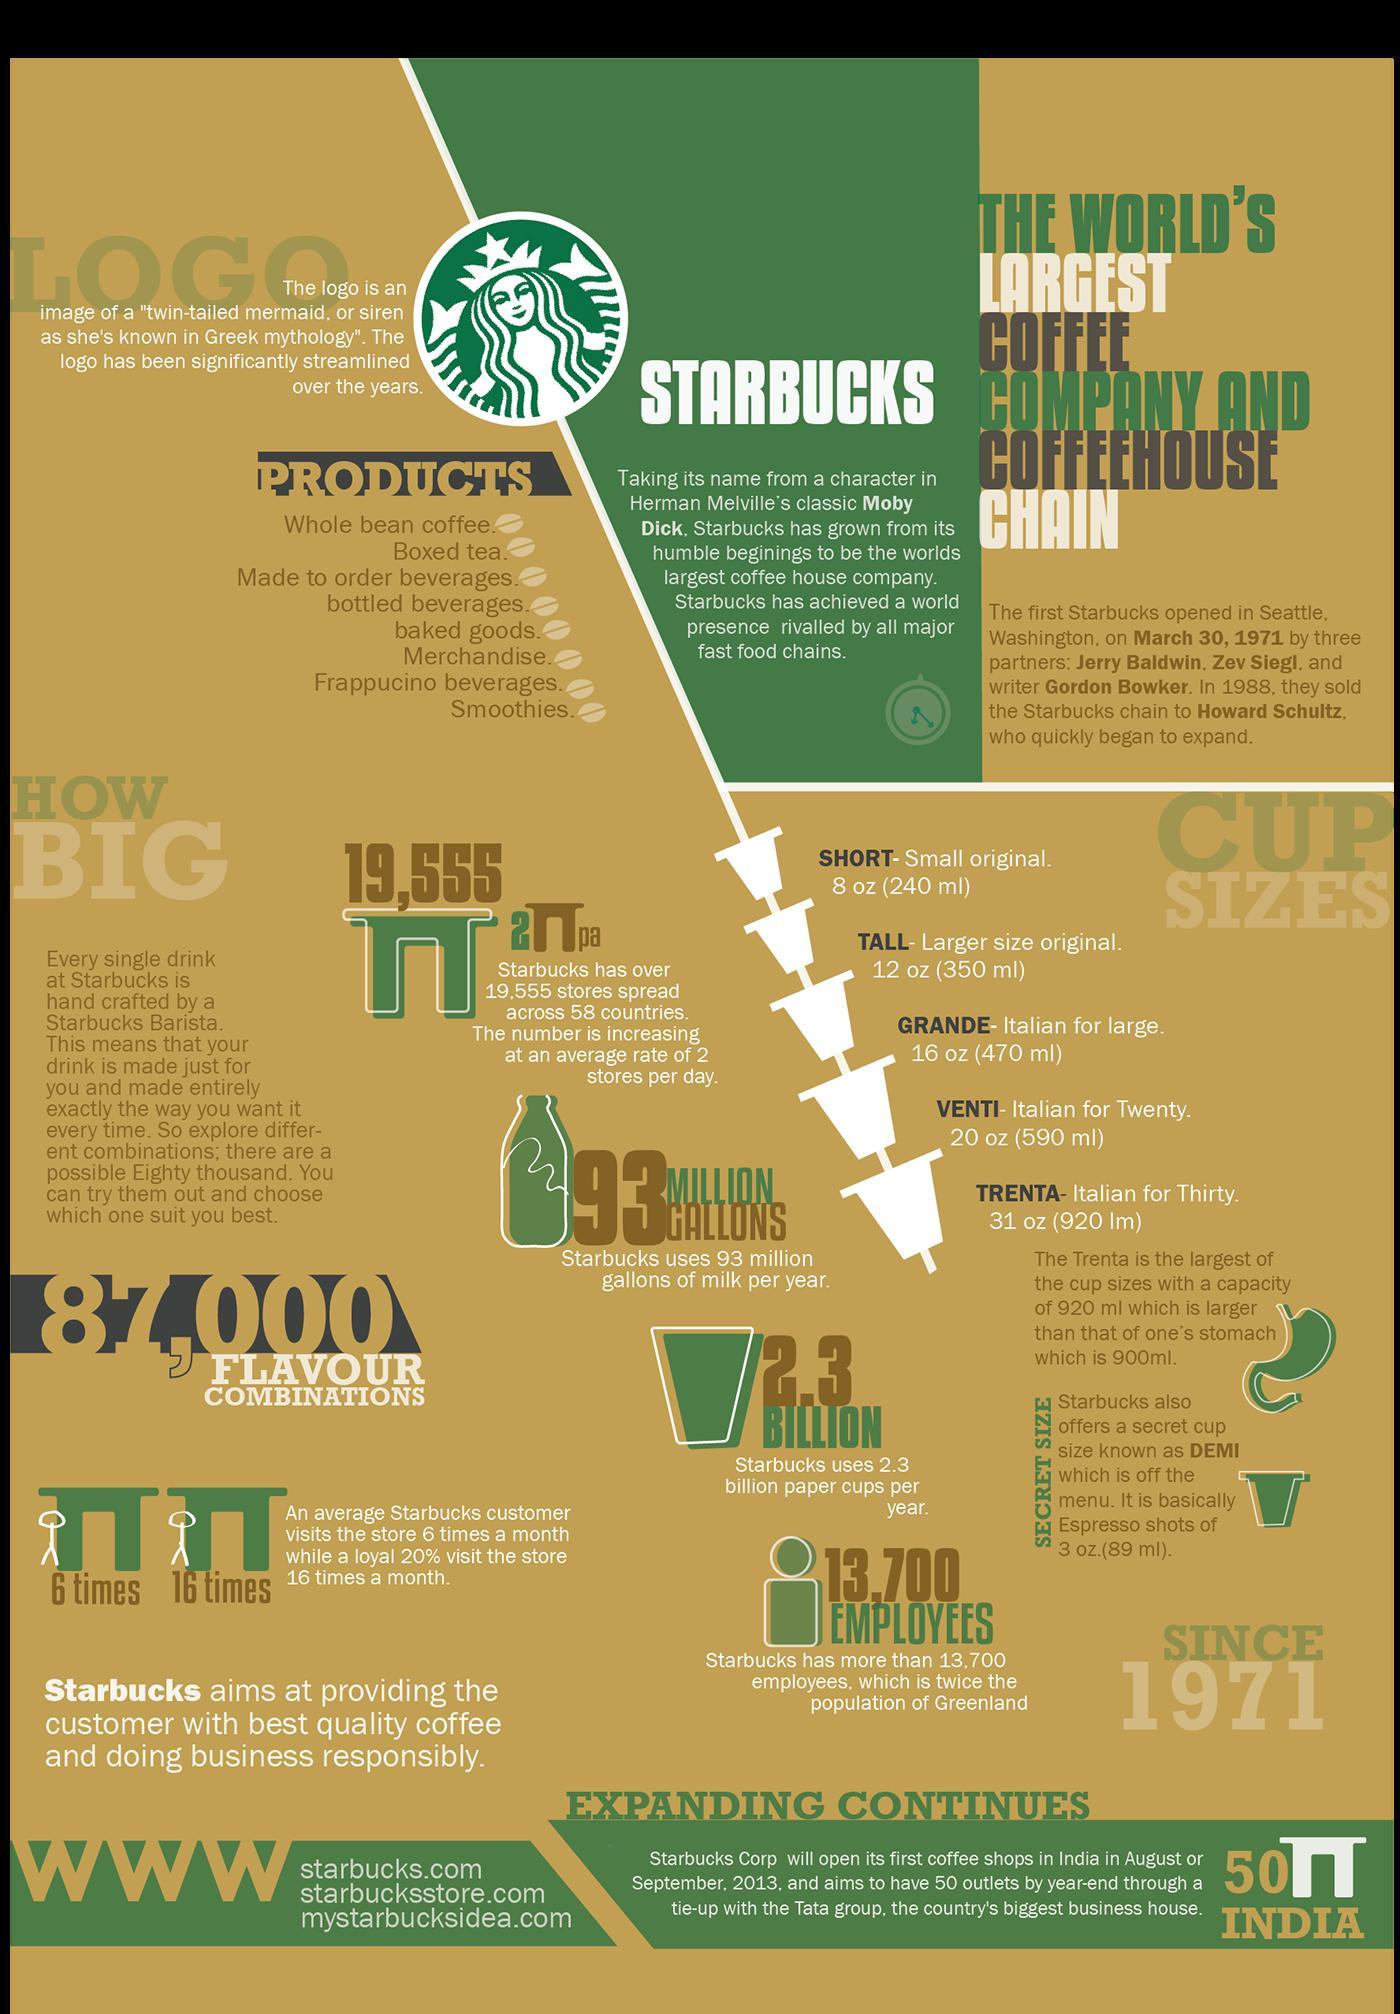how many product types are mentioned
Answer the question with a short phrase. 8 what is the difference in number of store visits per month by an average customer and loyal customer 10 which brand is being discussed starbucks what is a 590ml cup size called venti how many stores are being added per day 2 